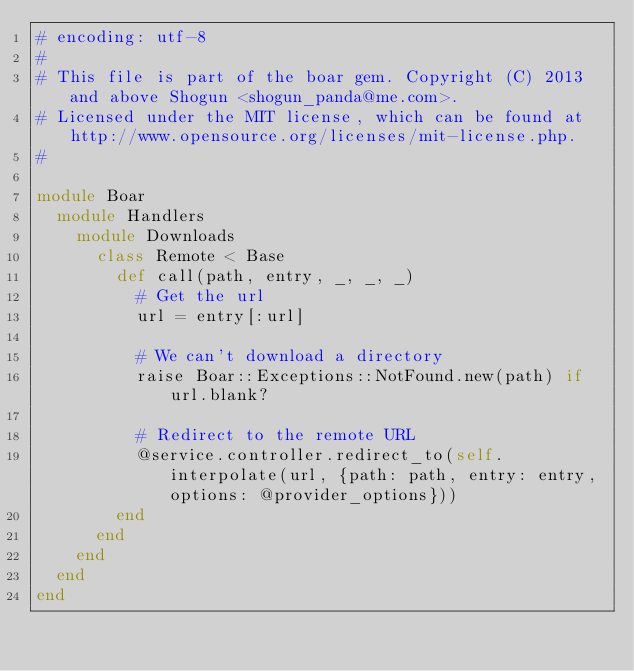Convert code to text. <code><loc_0><loc_0><loc_500><loc_500><_Ruby_># encoding: utf-8
#
# This file is part of the boar gem. Copyright (C) 2013 and above Shogun <shogun_panda@me.com>.
# Licensed under the MIT license, which can be found at http://www.opensource.org/licenses/mit-license.php.
#

module Boar
  module Handlers
    module Downloads
      class Remote < Base
        def call(path, entry, _, _, _)
          # Get the url
          url = entry[:url]

          # We can't download a directory
          raise Boar::Exceptions::NotFound.new(path) if url.blank?

          # Redirect to the remote URL
          @service.controller.redirect_to(self.interpolate(url, {path: path, entry: entry, options: @provider_options}))
        end
      end
    end
  end
end</code> 